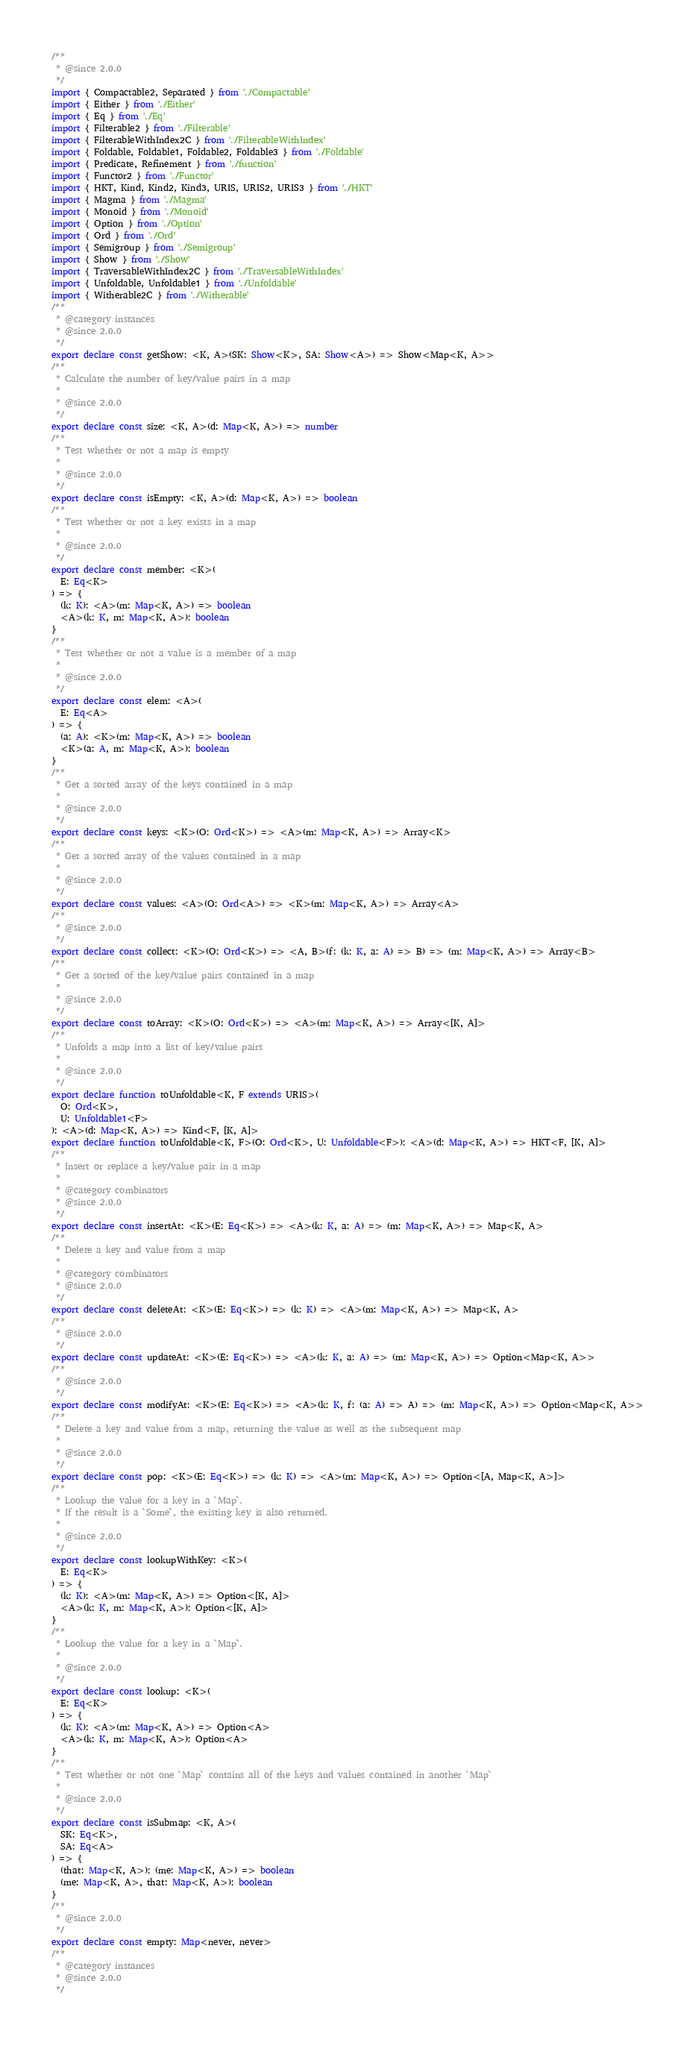Convert code to text. <code><loc_0><loc_0><loc_500><loc_500><_TypeScript_>/**
 * @since 2.0.0
 */
import { Compactable2, Separated } from './Compactable'
import { Either } from './Either'
import { Eq } from './Eq'
import { Filterable2 } from './Filterable'
import { FilterableWithIndex2C } from './FilterableWithIndex'
import { Foldable, Foldable1, Foldable2, Foldable3 } from './Foldable'
import { Predicate, Refinement } from './function'
import { Functor2 } from './Functor'
import { HKT, Kind, Kind2, Kind3, URIS, URIS2, URIS3 } from './HKT'
import { Magma } from './Magma'
import { Monoid } from './Monoid'
import { Option } from './Option'
import { Ord } from './Ord'
import { Semigroup } from './Semigroup'
import { Show } from './Show'
import { TraversableWithIndex2C } from './TraversableWithIndex'
import { Unfoldable, Unfoldable1 } from './Unfoldable'
import { Witherable2C } from './Witherable'
/**
 * @category instances
 * @since 2.0.0
 */
export declare const getShow: <K, A>(SK: Show<K>, SA: Show<A>) => Show<Map<K, A>>
/**
 * Calculate the number of key/value pairs in a map
 *
 * @since 2.0.0
 */
export declare const size: <K, A>(d: Map<K, A>) => number
/**
 * Test whether or not a map is empty
 *
 * @since 2.0.0
 */
export declare const isEmpty: <K, A>(d: Map<K, A>) => boolean
/**
 * Test whether or not a key exists in a map
 *
 * @since 2.0.0
 */
export declare const member: <K>(
  E: Eq<K>
) => {
  (k: K): <A>(m: Map<K, A>) => boolean
  <A>(k: K, m: Map<K, A>): boolean
}
/**
 * Test whether or not a value is a member of a map
 *
 * @since 2.0.0
 */
export declare const elem: <A>(
  E: Eq<A>
) => {
  (a: A): <K>(m: Map<K, A>) => boolean
  <K>(a: A, m: Map<K, A>): boolean
}
/**
 * Get a sorted array of the keys contained in a map
 *
 * @since 2.0.0
 */
export declare const keys: <K>(O: Ord<K>) => <A>(m: Map<K, A>) => Array<K>
/**
 * Get a sorted array of the values contained in a map
 *
 * @since 2.0.0
 */
export declare const values: <A>(O: Ord<A>) => <K>(m: Map<K, A>) => Array<A>
/**
 * @since 2.0.0
 */
export declare const collect: <K>(O: Ord<K>) => <A, B>(f: (k: K, a: A) => B) => (m: Map<K, A>) => Array<B>
/**
 * Get a sorted of the key/value pairs contained in a map
 *
 * @since 2.0.0
 */
export declare const toArray: <K>(O: Ord<K>) => <A>(m: Map<K, A>) => Array<[K, A]>
/**
 * Unfolds a map into a list of key/value pairs
 *
 * @since 2.0.0
 */
export declare function toUnfoldable<K, F extends URIS>(
  O: Ord<K>,
  U: Unfoldable1<F>
): <A>(d: Map<K, A>) => Kind<F, [K, A]>
export declare function toUnfoldable<K, F>(O: Ord<K>, U: Unfoldable<F>): <A>(d: Map<K, A>) => HKT<F, [K, A]>
/**
 * Insert or replace a key/value pair in a map
 *
 * @category combinators
 * @since 2.0.0
 */
export declare const insertAt: <K>(E: Eq<K>) => <A>(k: K, a: A) => (m: Map<K, A>) => Map<K, A>
/**
 * Delete a key and value from a map
 *
 * @category combinators
 * @since 2.0.0
 */
export declare const deleteAt: <K>(E: Eq<K>) => (k: K) => <A>(m: Map<K, A>) => Map<K, A>
/**
 * @since 2.0.0
 */
export declare const updateAt: <K>(E: Eq<K>) => <A>(k: K, a: A) => (m: Map<K, A>) => Option<Map<K, A>>
/**
 * @since 2.0.0
 */
export declare const modifyAt: <K>(E: Eq<K>) => <A>(k: K, f: (a: A) => A) => (m: Map<K, A>) => Option<Map<K, A>>
/**
 * Delete a key and value from a map, returning the value as well as the subsequent map
 *
 * @since 2.0.0
 */
export declare const pop: <K>(E: Eq<K>) => (k: K) => <A>(m: Map<K, A>) => Option<[A, Map<K, A>]>
/**
 * Lookup the value for a key in a `Map`.
 * If the result is a `Some`, the existing key is also returned.
 *
 * @since 2.0.0
 */
export declare const lookupWithKey: <K>(
  E: Eq<K>
) => {
  (k: K): <A>(m: Map<K, A>) => Option<[K, A]>
  <A>(k: K, m: Map<K, A>): Option<[K, A]>
}
/**
 * Lookup the value for a key in a `Map`.
 *
 * @since 2.0.0
 */
export declare const lookup: <K>(
  E: Eq<K>
) => {
  (k: K): <A>(m: Map<K, A>) => Option<A>
  <A>(k: K, m: Map<K, A>): Option<A>
}
/**
 * Test whether or not one `Map` contains all of the keys and values contained in another `Map`
 *
 * @since 2.0.0
 */
export declare const isSubmap: <K, A>(
  SK: Eq<K>,
  SA: Eq<A>
) => {
  (that: Map<K, A>): (me: Map<K, A>) => boolean
  (me: Map<K, A>, that: Map<K, A>): boolean
}
/**
 * @since 2.0.0
 */
export declare const empty: Map<never, never>
/**
 * @category instances
 * @since 2.0.0
 */</code> 